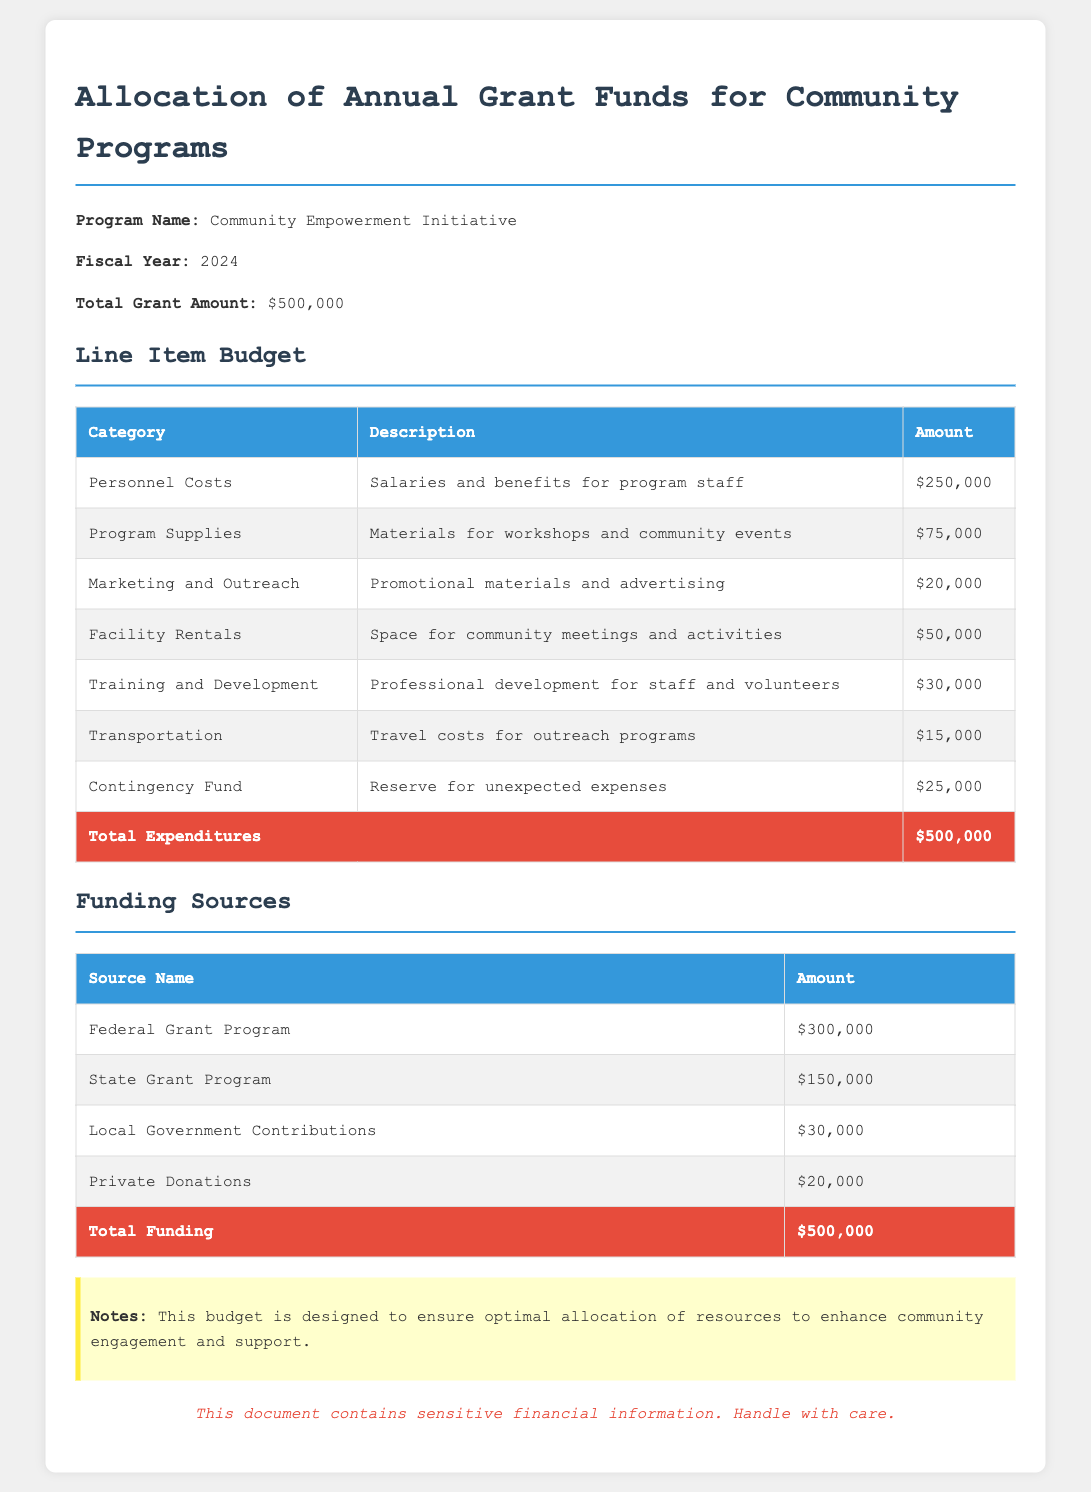What is the total grant amount? The total grant amount is mentioned as $500,000 in the document.
Answer: $500,000 How much is allocated for Personnel Costs? The budget allocates $250,000 for Personnel Costs, as detailed in the line item budget.
Answer: $250,000 What is the amount for Marketing and Outreach? The document states that $20,000 is allocated for Marketing and Outreach.
Answer: $20,000 Which funding source contributes the most? The Federal Grant Program contributes the most with an amount of $300,000.
Answer: Federal Grant Program What is the total amount allocated for Facility Rentals? The total amount allocated for Facility Rentals is provided as $50,000 in the budget.
Answer: $50,000 How much is reserved in the Contingency Fund? The Contingency Fund is set at $25,000 according to the line-item breakdown.
Answer: $25,000 What is the total amount received from Private Donations? The document indicates that the amount received from Private Donations is $20,000.
Answer: $20,000 What is the purpose of the Training and Development expense? The purpose is for professional development for staff and volunteers, as described in the budget.
Answer: Professional development What notes are provided regarding the budget? The notes emphasize optimal allocation of resources to enhance community engagement and support.
Answer: Optimal allocation of resources What is the total funding amount listed in the document? The total funding amount listed in the document is $500,000.
Answer: $500,000 